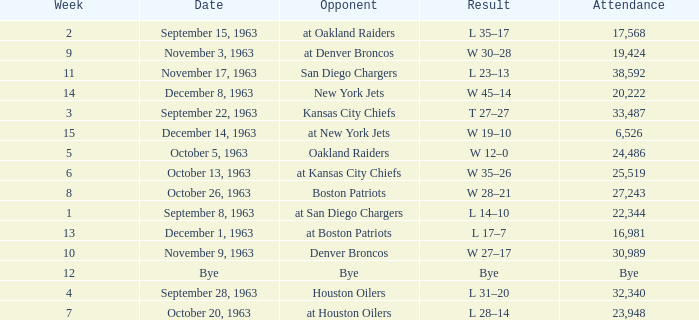Which Opponent has a Result of l 14–10? At san diego chargers. 